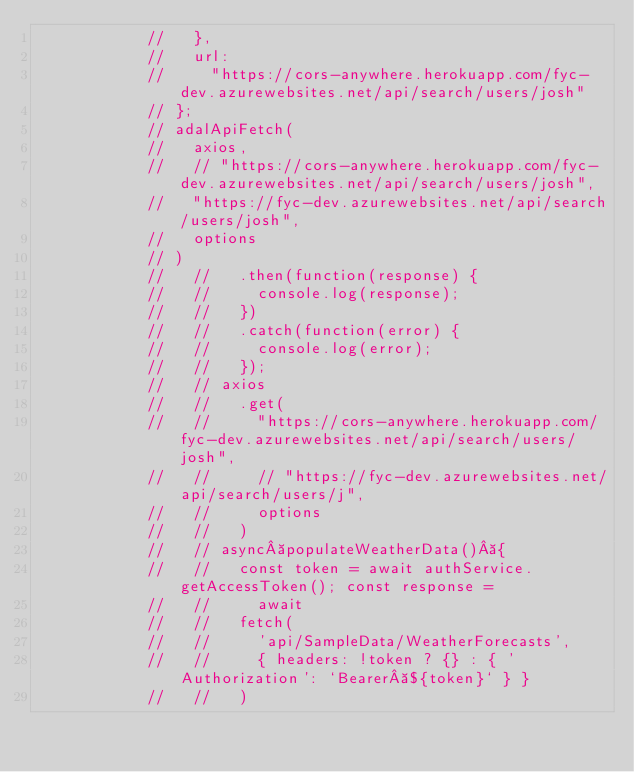<code> <loc_0><loc_0><loc_500><loc_500><_JavaScript_>            //   },
            //   url:
            //     "https://cors-anywhere.herokuapp.com/fyc-dev.azurewebsites.net/api/search/users/josh"
            // };
            // adalApiFetch(
            //   axios,
            //   // "https://cors-anywhere.herokuapp.com/fyc-dev.azurewebsites.net/api/search/users/josh",
            //   "https://fyc-dev.azurewebsites.net/api/search/users/josh",
            //   options
            // )
            //   //   .then(function(response) {
            //   //     console.log(response);
            //   //   })
            //   //   .catch(function(error) {
            //   //     console.log(error);
            //   //   });
            //   // axios
            //   //   .get(
            //   //     "https://cors-anywhere.herokuapp.com/fyc-dev.azurewebsites.net/api/search/users/josh",
            //   //     // "https://fyc-dev.azurewebsites.net/api/search/users/j",
            //   //     options
            //   //   )
            //   // async populateWeatherData() {
            //   //   const token = await authService.getAccessToken(); const response =
            //   //     await
            //   //   fetch(
            //   //     'api/SampleData/WeatherForecasts',
            //   //     { headers: !token ? {} : { 'Authorization': `Bearer ${token}` } }
            //   //   )</code> 